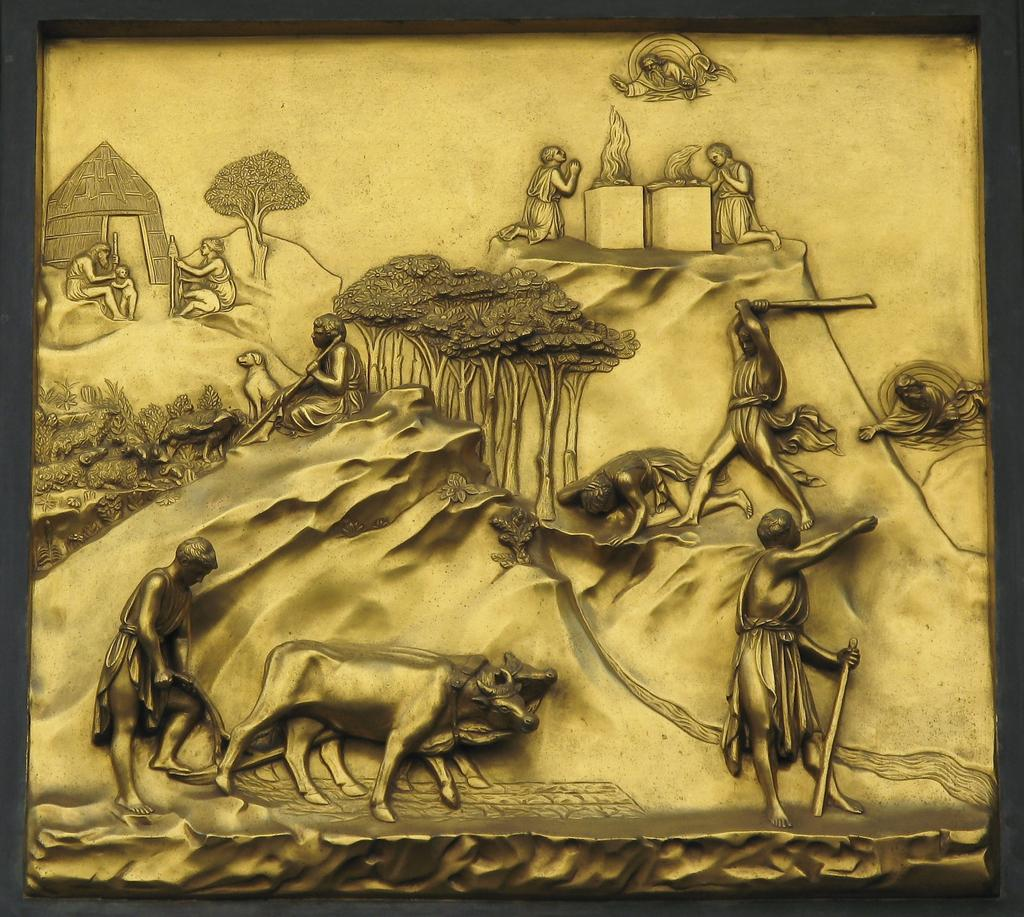What is the main subject of the image? The main subject of the image is a frame. What types of elements are depicted within the frame? The frame contains depictions of animals, persons, trees, and a house. What type of girl can be seen playing in the range during summer in the image? There is no girl or range present in the image; it features a frame with depictions of animals, persons, trees, and a house. 